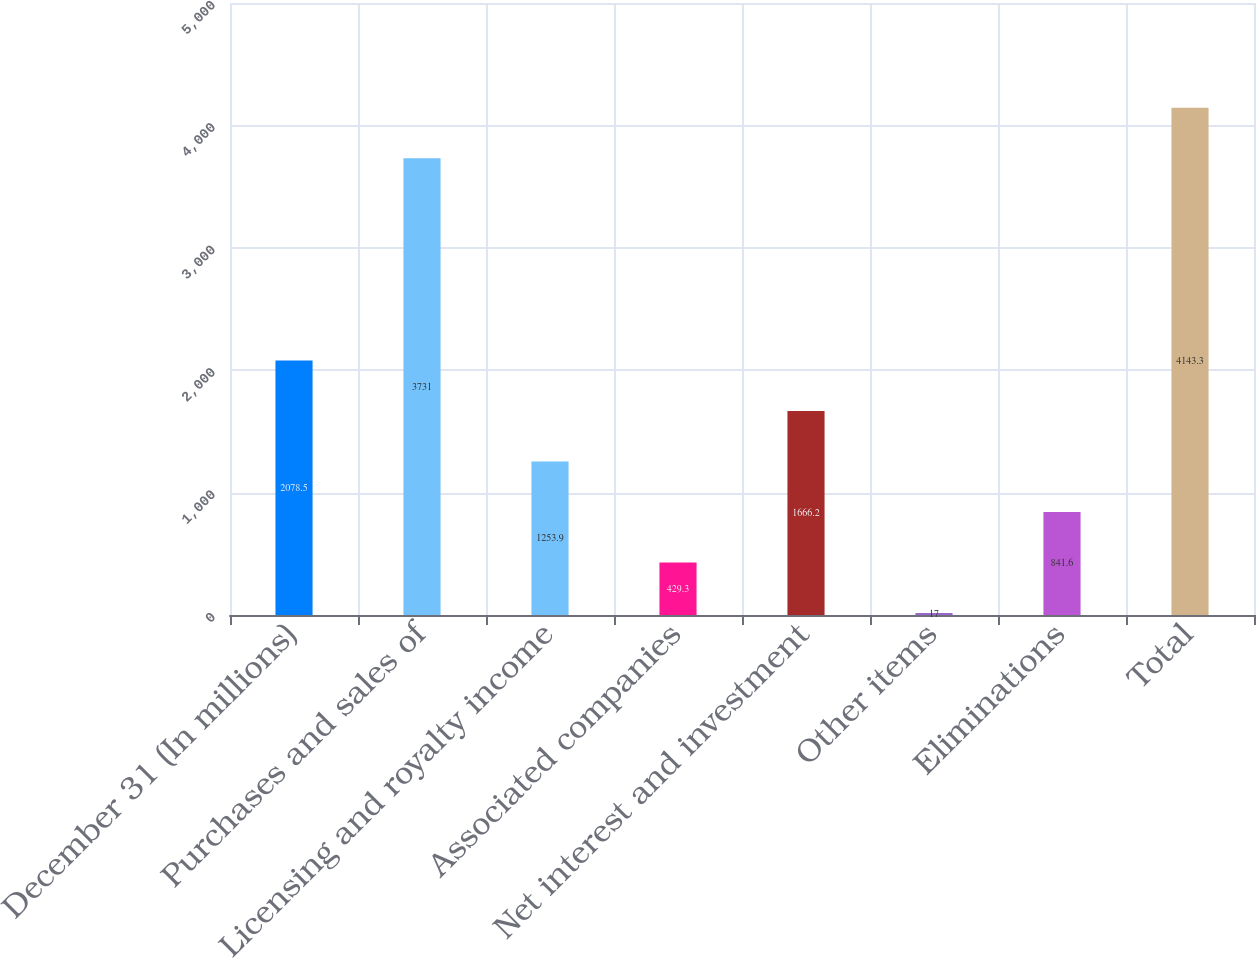Convert chart. <chart><loc_0><loc_0><loc_500><loc_500><bar_chart><fcel>December 31 (In millions)<fcel>Purchases and sales of<fcel>Licensing and royalty income<fcel>Associated companies<fcel>Net interest and investment<fcel>Other items<fcel>Eliminations<fcel>Total<nl><fcel>2078.5<fcel>3731<fcel>1253.9<fcel>429.3<fcel>1666.2<fcel>17<fcel>841.6<fcel>4143.3<nl></chart> 